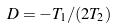Convert formula to latex. <formula><loc_0><loc_0><loc_500><loc_500>D = - T _ { 1 } / ( 2 T _ { 2 } )</formula> 